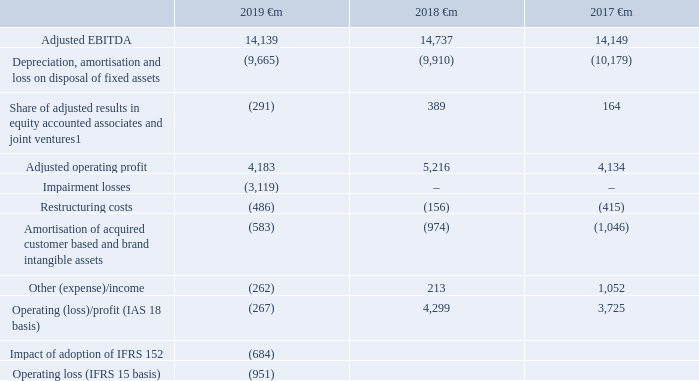The Group’s measure of segment profit, adjusted EBITDA, excludes depreciation, amortisation, impairment loss, restructuring costs, loss on disposal of fixed assets, the Group’s share of results in associates and joint ventures and other income and expense. A reconciliation of adjusted EBITDA to operating profit is shown below. For a reconciliation of operating profit to profit for the financial year, see the Consolidated income statement on page 111.
Note: 1 Share of adjusted results in equity accounted associates and joint ventures excludes amortisation of acquired customer bases and brand intangible assets, restructuring costs and other costs of €0.6 billion (2018: €0.4 billion, 2017: €0.1 billion) which are included in amortisation of acquired customer base and brand intangible assets, restructuring costs and other income and expense respectively
2 See note 31 “IAS 18 basis primary statements” for further details.
How much is the excluded depreciation and amortisation for 2019 adjusted EBITDA?
Answer scale should be: million. (9,665). How much is the excluded depreciation and amortisation for 2018 adjusted EBITDA?
Answer scale should be: million. (9,910). How much is the 2019 adjusted EBITDA?
Answer scale should be: million. 14,139. How much is the average adjusted EBITDA between 2018 and 2019?
Answer scale should be: million. (14,139+14,737)/2
Answer: 14438. How much is the average adjusted EBITDA between 2018 and 2017?
Answer scale should be: million. (14,737+14,149)/2
Answer: 14443. What is the change in average adjusted EBITDA between 2018 and 2019, and 2017 and 2018?
Answer scale should be: million. [(14,139+14,737)/2] - [(14,737+14,149)/2]
Answer: -5. 